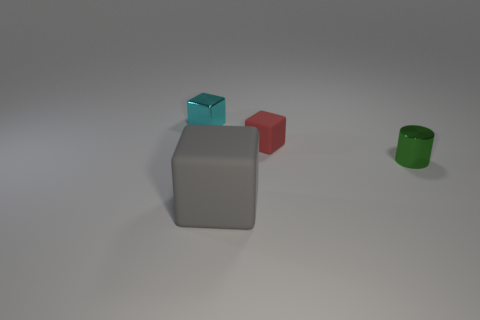Add 1 tiny purple matte objects. How many objects exist? 5 Subtract all cubes. How many objects are left? 1 Add 4 big blue objects. How many big blue objects exist? 4 Subtract 0 cyan balls. How many objects are left? 4 Subtract all metal things. Subtract all big cyan things. How many objects are left? 2 Add 1 big objects. How many big objects are left? 2 